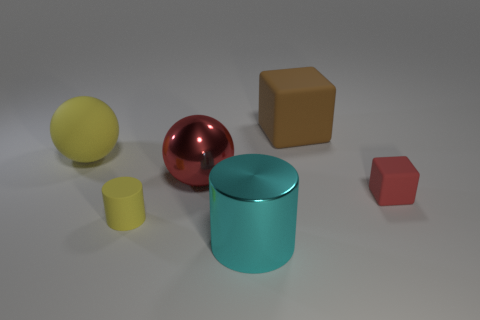There is a red object that is the same size as the yellow cylinder; what is its material?
Ensure brevity in your answer.  Rubber. There is a large object that is right of the big red shiny thing and on the left side of the large brown cube; what is its shape?
Make the answer very short. Cylinder. There is a matte block that is the same size as the matte ball; what is its color?
Give a very brief answer. Brown. Does the metallic sphere left of the big brown thing have the same size as the block in front of the brown cube?
Keep it short and to the point. No. What size is the cube that is to the left of the cube that is in front of the ball that is to the left of the red metal ball?
Make the answer very short. Large. There is a big rubber thing behind the large matte thing to the left of the brown block; what shape is it?
Offer a very short reply. Cube. Do the cylinder to the left of the cyan object and the large cylinder have the same color?
Offer a very short reply. No. There is a thing that is on the left side of the cyan shiny cylinder and in front of the red rubber object; what is its color?
Make the answer very short. Yellow. Is there a big red thing that has the same material as the cyan object?
Provide a short and direct response. Yes. How big is the brown cube?
Keep it short and to the point. Large. 